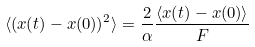Convert formula to latex. <formula><loc_0><loc_0><loc_500><loc_500>\langle ( x ( t ) - x ( 0 ) ) ^ { 2 } \rangle = \frac { 2 } { \alpha } \frac { \langle x ( t ) - x ( 0 ) \rangle } { F }</formula> 